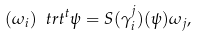Convert formula to latex. <formula><loc_0><loc_0><loc_500><loc_500>( \omega _ { i } ) \ t r t ^ { t } \psi = S ( \gamma _ { i } ^ { j } ) ( \psi ) { \omega } _ { j } ,</formula> 